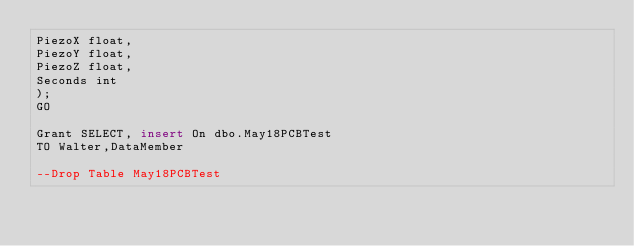<code> <loc_0><loc_0><loc_500><loc_500><_SQL_>PiezoX float,
PiezoY float,
PiezoZ float,
Seconds int
);
GO

Grant SELECT, insert On dbo.May18PCBTest
TO Walter,DataMember

--Drop Table May18PCBTest</code> 